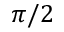<formula> <loc_0><loc_0><loc_500><loc_500>\pi / 2</formula> 